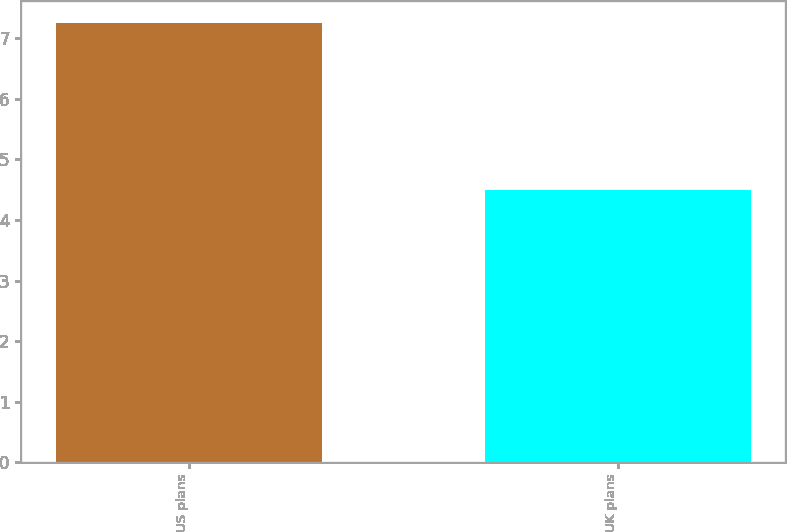Convert chart. <chart><loc_0><loc_0><loc_500><loc_500><bar_chart><fcel>US plans<fcel>UK plans<nl><fcel>7.25<fcel>4.5<nl></chart> 